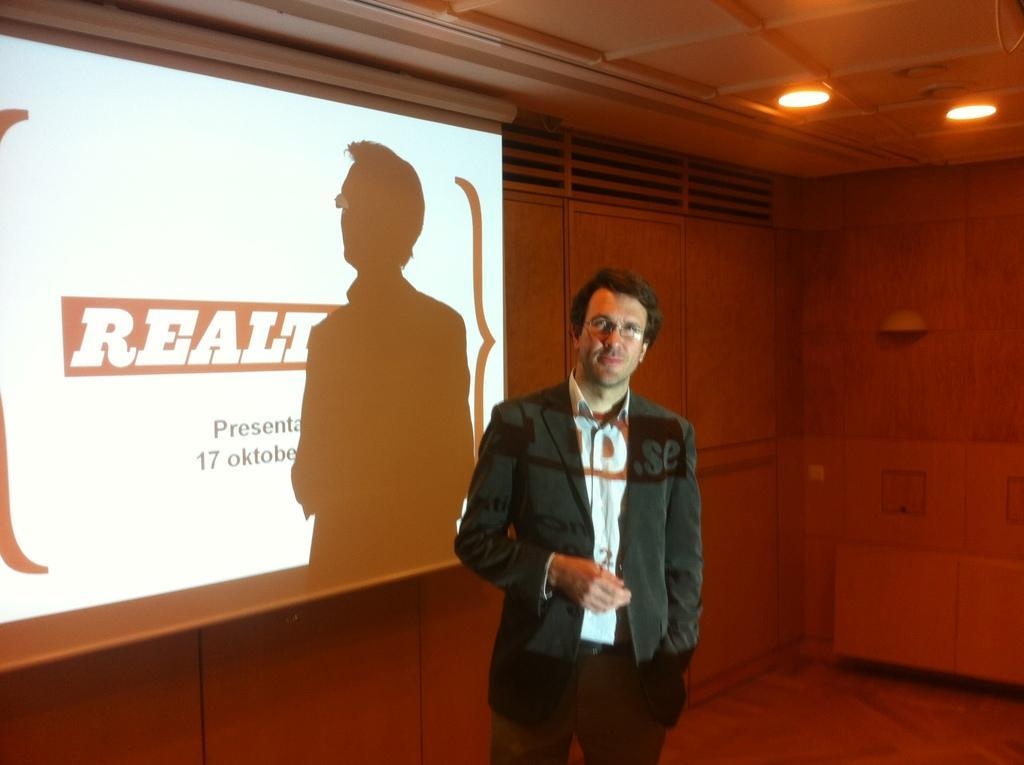How would you summarize this image in a sentence or two? in this picture there is a man standing, behind him we can see a screen, lights and vents. 